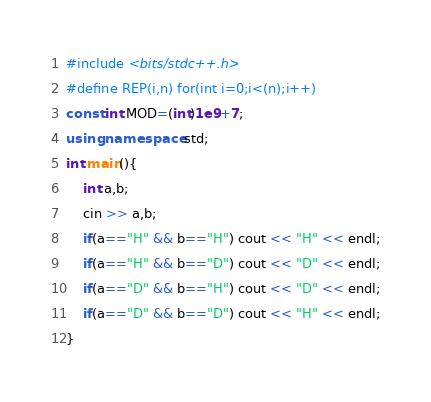Convert code to text. <code><loc_0><loc_0><loc_500><loc_500><_C++_>#include <bits/stdc++.h>
#define REP(i,n) for(int i=0;i<(n);i++)
const int MOD=(int)1e9+7;
using namespace std;
int main(){
    int a,b;
    cin >> a,b;
    if(a=="H" && b=="H") cout << "H" << endl;
    if(a=="H" && b=="D") cout << "D" << endl;
    if(a=="D" && b=="H") cout << "D" << endl;
    if(a=="D" && b=="D") cout << "H" << endl;
}</code> 